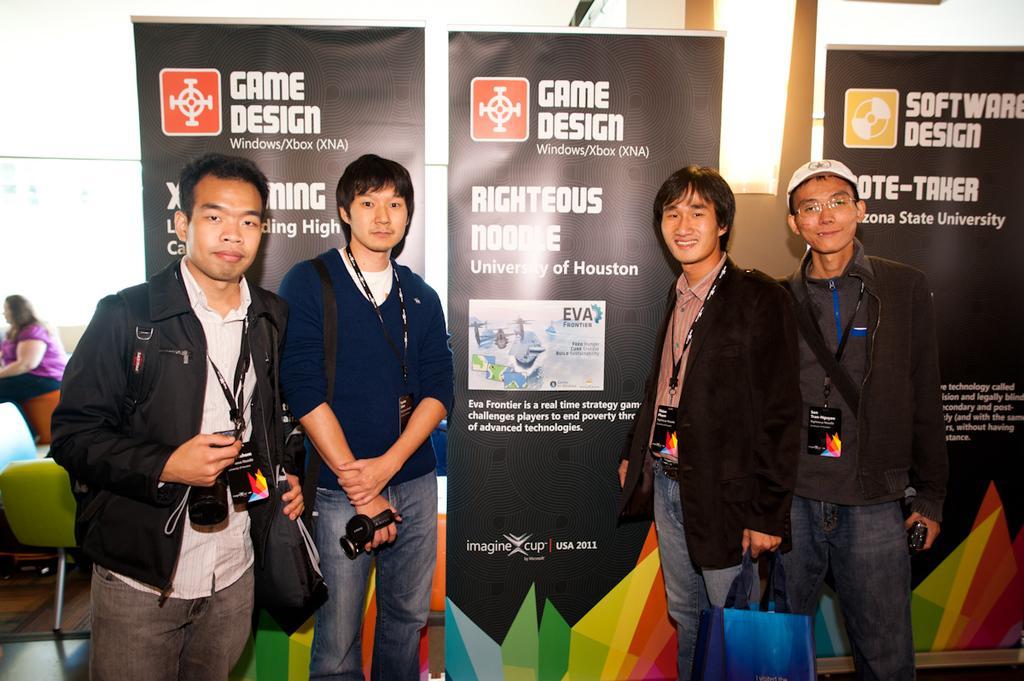Please provide a concise description of this image. In this image we can see four men are standing. In the background, we can see the banners and the light. On the left side of the image, we can see chairs and a woman. We can see one man is wearing a hoodie with jeans and holding black color object in the hand. The other man is wearing a shirt, black coat, jeans and holding carry bag in his hand. The third man is wearing sweater, jeans and holding camera in his hand. The fourth man is wearing a shirt, jeans, coat and carrying a camera and bag. 